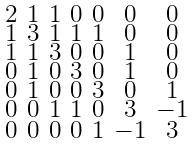Convert formula to latex. <formula><loc_0><loc_0><loc_500><loc_500>\begin{smallmatrix} 2 & 1 & 1 & 0 & 0 & 0 & 0 \\ 1 & 3 & 1 & 1 & 1 & 0 & 0 \\ 1 & 1 & 3 & 0 & 0 & 1 & 0 \\ 0 & 1 & 0 & 3 & 0 & 1 & 0 \\ 0 & 1 & 0 & 0 & 3 & 0 & 1 \\ 0 & 0 & 1 & 1 & 0 & 3 & - 1 \\ 0 & 0 & 0 & 0 & 1 & - 1 & 3 \end{smallmatrix}</formula> 